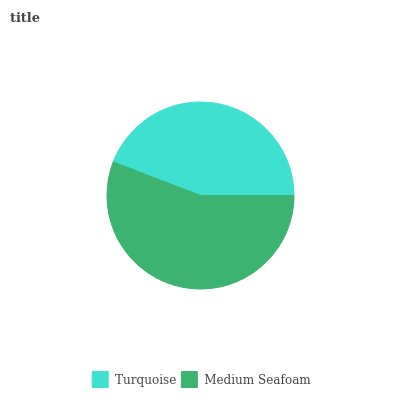Is Turquoise the minimum?
Answer yes or no. Yes. Is Medium Seafoam the maximum?
Answer yes or no. Yes. Is Medium Seafoam the minimum?
Answer yes or no. No. Is Medium Seafoam greater than Turquoise?
Answer yes or no. Yes. Is Turquoise less than Medium Seafoam?
Answer yes or no. Yes. Is Turquoise greater than Medium Seafoam?
Answer yes or no. No. Is Medium Seafoam less than Turquoise?
Answer yes or no. No. Is Medium Seafoam the high median?
Answer yes or no. Yes. Is Turquoise the low median?
Answer yes or no. Yes. Is Turquoise the high median?
Answer yes or no. No. Is Medium Seafoam the low median?
Answer yes or no. No. 